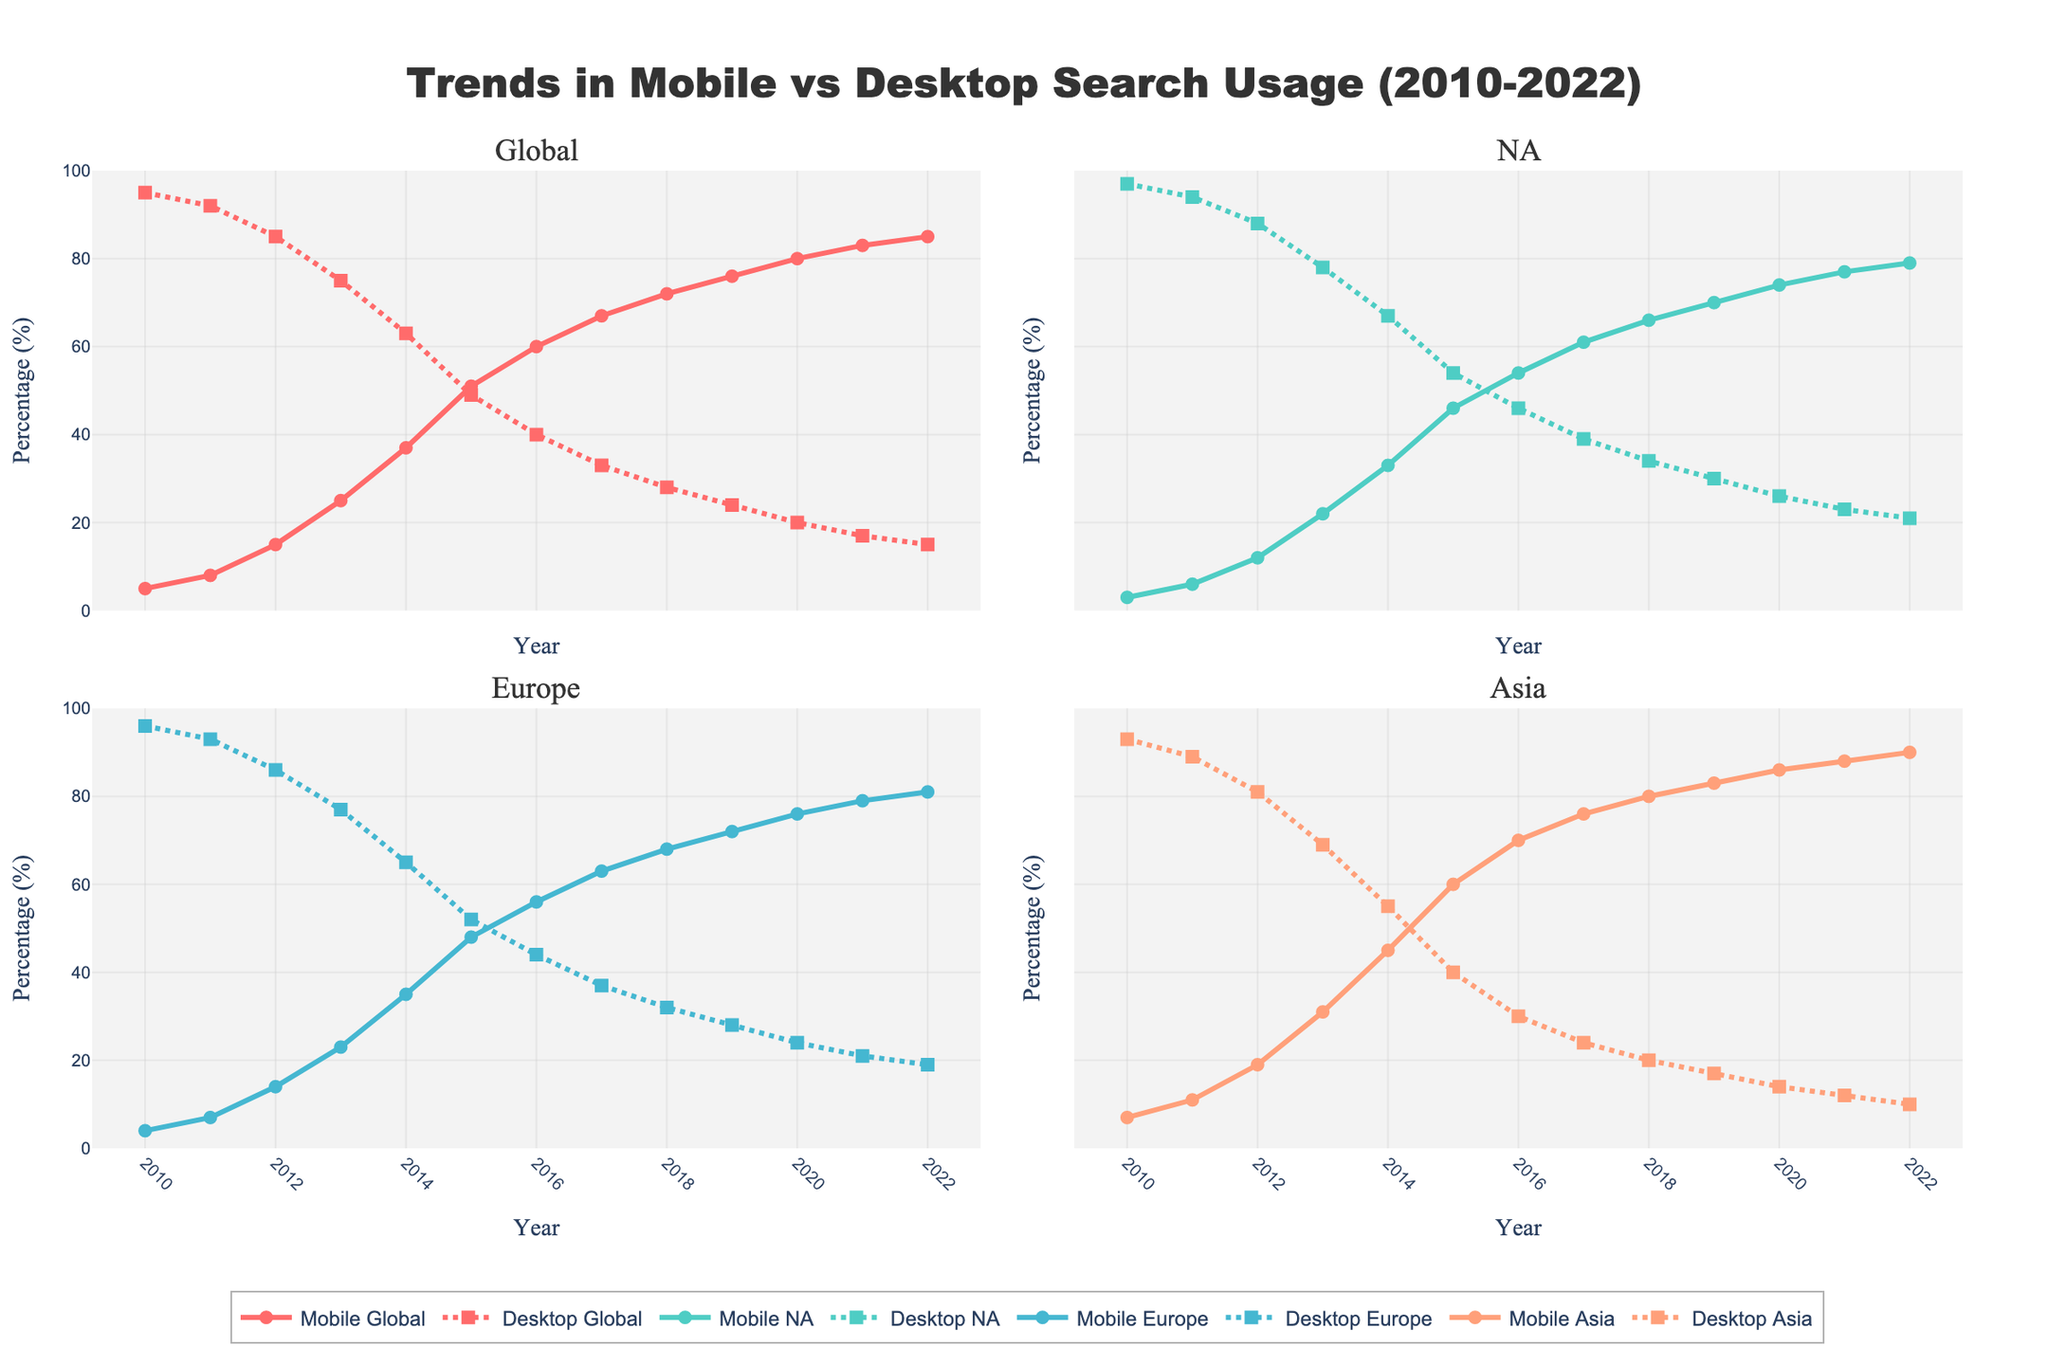What trend can be observed for global mobile search usage from 2010 to 2022? To determine the trend of global mobile search usage, inspect the line representing mobile global search over the years. It starts at 5% in 2010 and increases steadily, reaching 85% in 2022. This shows a clear rising trend.
Answer: Rising trend Which region had the highest mobile search usage in 2012? To find the highest mobile search usage by region in 2012, compare the mobile usage percentages for North America, Europe, and Asia. Asia has the highest value at 19%, compared to 12% in North America and 14% in Europe.
Answer: Asia By how many percentage points did desktop search usage decrease globally from 2010 to 2022? Desktop global search usage starts at 95% in 2010 and decreases to 15% in 2022. The percentage point decrease is 95% - 15%.
Answer: 80 percentage points Which year did mobile search usage surpass desktop search usage globally? Look for the year when the mobile search line crosses above the desktop search line on the global subplot. This occurs in 2015, where mobile usage is 51% and desktop usage is 49%.
Answer: 2015 In which region was the gap between mobile and desktop search usage the largest in 2022? Compare the difference between mobile and desktop percentages for each region in 2022. Asia has the largest gap (90% - 10% = 80%), compared with Global (85% - 15%), North America (79% - 21%), and Europe (81% - 19%).
Answer: Asia What was the average mobile search usage across all regions in 2016? Calculate the average of mobile search usage in Global, North America, Europe, and Asia for 2016: (60 + 54 + 56 + 70) / 4.
Answer: 60% How much did mobile search usage in North America increase from 2010 to 2013? Find the mobile search usage percentages for North America in 2010 (3%) and 2013 (22%), then calculate the increase: 22% - 3%.
Answer: 19 percentage points Which region exhibited the fastest growth in mobile search usage between 2010 and 2020? Compute the increase for each region over the period from 2010 to 2020. Asia's mobile usage grew from 7% to 86%, an increase of 79 percentage points, which is higher than the increases in Global (75%), North America (71%), and Europe (72%).
Answer: Asia 